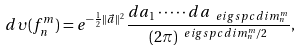<formula> <loc_0><loc_0><loc_500><loc_500>d \upsilon ( f ^ { m } _ { n } ) = e ^ { - \frac { 1 } { 2 } \| \vec { a } \| ^ { 2 } } \frac { d a _ { 1 } \cdot \dots \cdot d a _ { \ e i g s p c d i m _ { n } ^ { m } } } { ( 2 \pi ) ^ { \ e i g s p c d i m _ { n } ^ { m } / 2 } } ,</formula> 